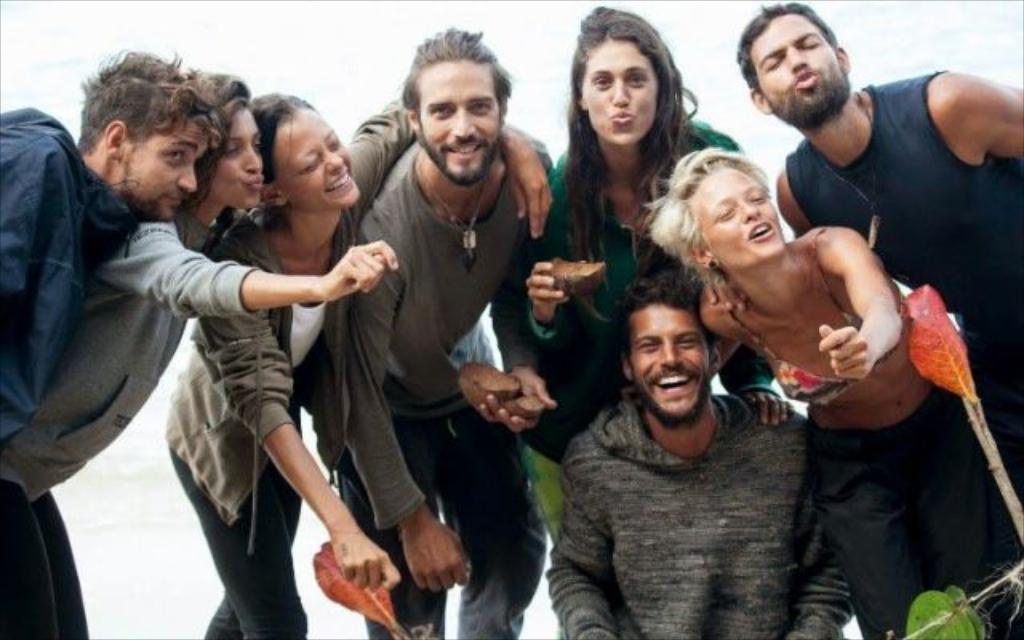How many people are present in the image? There are eight people in the image. What can be seen on the right side of the image? There is a small plant on the right side of the image. What is the woman in the front of the image holding? The woman is holding a leaf in the front of the image. What is visible in the background of the image? The sky is visible in the background of the image. What type of crate is being used to store the flesh in the image? There is no crate or flesh present in the image. Can you describe the cat's behavior in the image? There is no cat present in the image. 